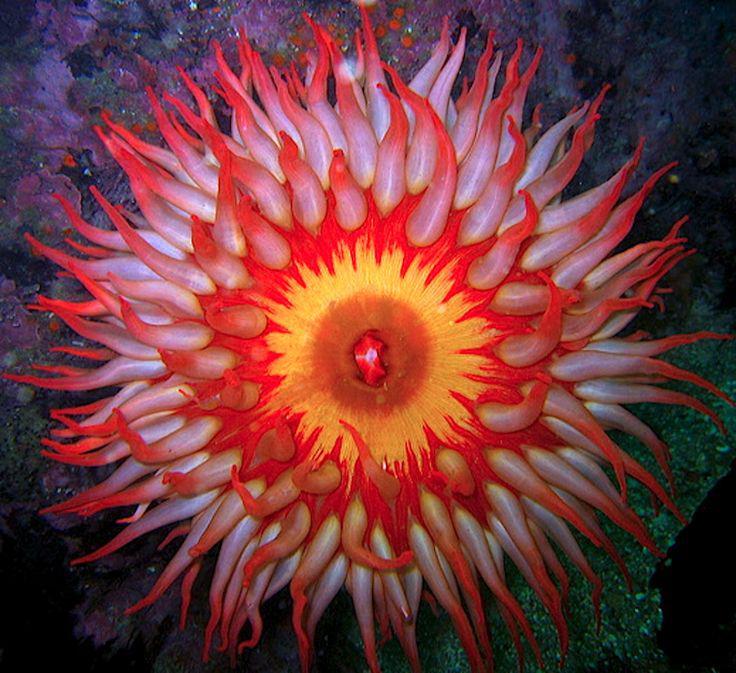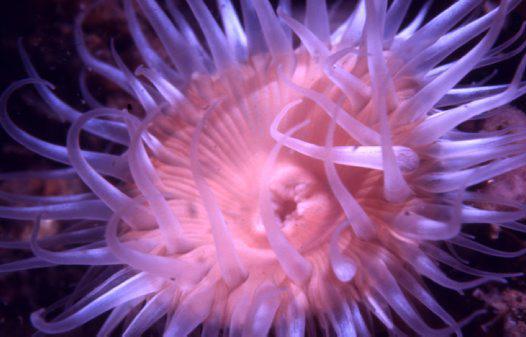The first image is the image on the left, the second image is the image on the right. Assess this claim about the two images: "Exactly one clownfish swims near the center of an image, amid anemone tendrils.". Correct or not? Answer yes or no. No. 